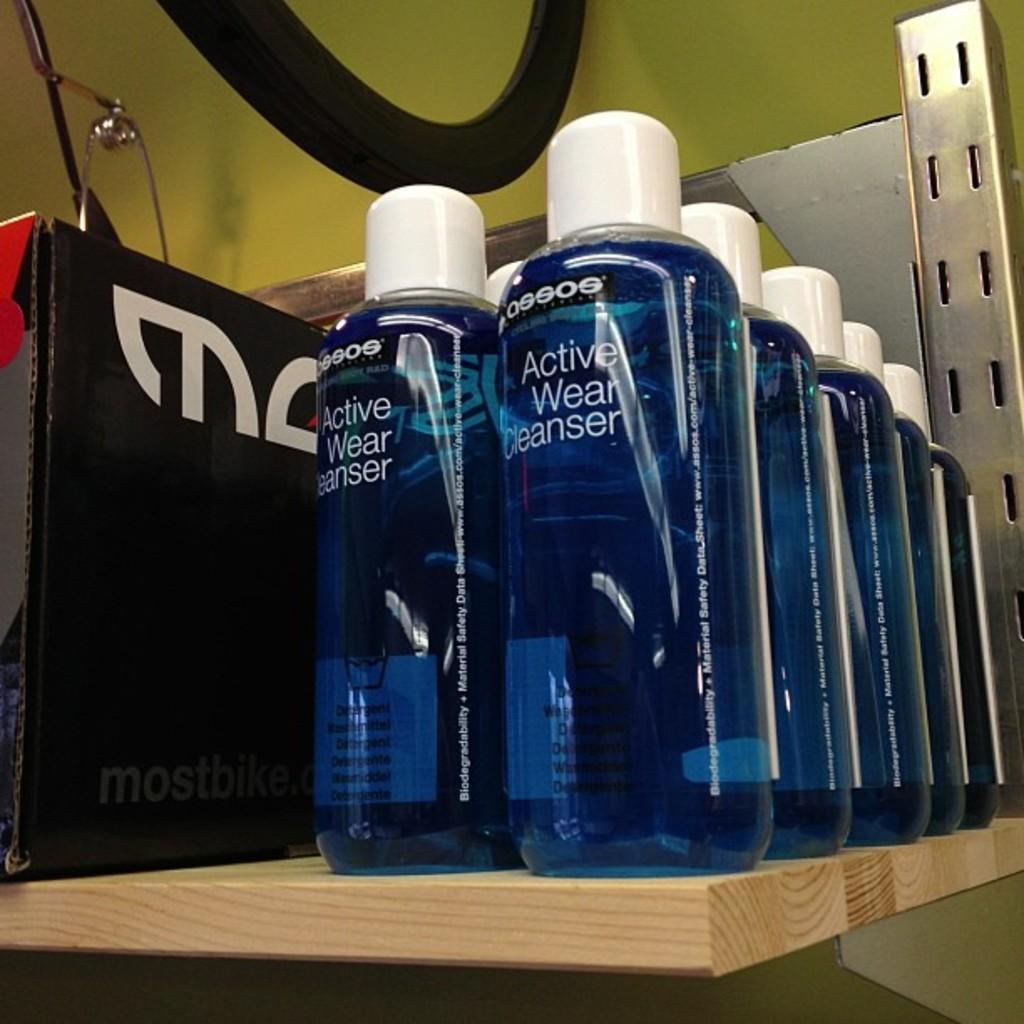<image>
Write a terse but informative summary of the picture. Several bottles of Active Wear Cleanser on a shelf 